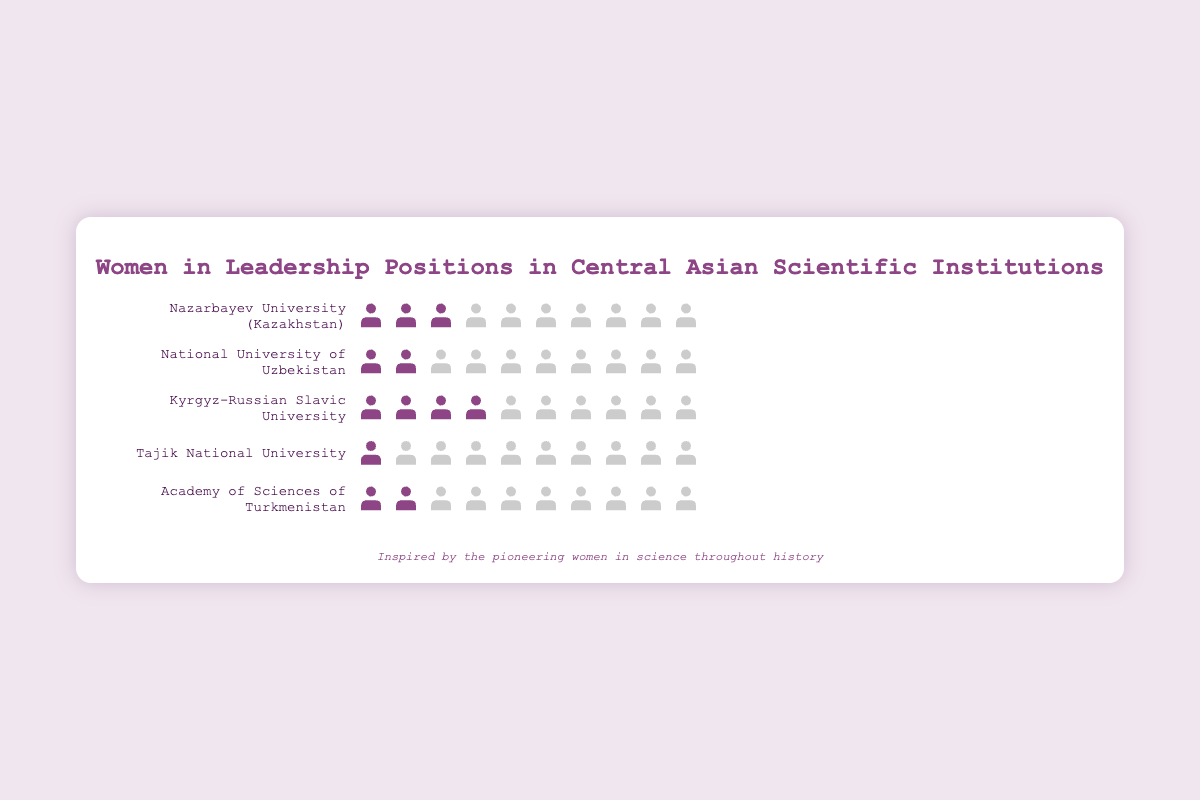What is the title of the Isotype Plot? The title of the Isotype Plot is located at the top of the chart and provides a summary of the plot’s content, indicating that the figure is about women in leadership positions in Central Asian scientific institutions.
Answer: Women in Leadership Positions in Central Asian Scientific Institutions Which institution has the highest number of women leaders? By counting the number of women's icons (figures with purple) for each institution row-wise, it appears that the Kyrgyz-Russian Slavic University has the highest number of women leaders.
Answer: Kyrgyz-Russian Slavic University How many men leaders are there in the Academy of Sciences of Turkmenistan? The Academy of Sciences of Turkmenistan has two women leaders. Since there are 10 total leaders, the number of men leaders is the difference between the total leaders and women leaders, which is 10 - 2.
Answer: 8 Compare the number of women leaders in Nazarbayev University and Tajik National University. Which one has more women leaders and by how much? Nazarbayev University has 3 women leaders and Tajik National University has 1. The difference in the number of women leaders between these two institutions is 3 - 1.
Answer: Nazarbayev University by 2 What percentage of leaders in the Kyrgyz-Russian Slavic University are women? The Kyrgyz-Russian Slavic University has 4 women leaders out of a total of 10. To find the percentage of women leaders, divide the number of women leaders by the total number of leaders and multiply by 100, or (4 / 10) * 100.
Answer: 40% How many institutions have exactly 2 women leaders? Count the rows where exactly two women’s icons (figures with purple) are present. These institutions are the National University of Uzbekistan and the Academy of Sciences of Turkmenistan.
Answer: 2 Which institution out of all the listed has the lowest representation of women in leadership positions? The institution with the lowest number of women’s icons (figures with purple) is the Tajik National University with only one woman leader.
Answer: Tajik National University What is the total number of women leaders across all listed institutions? Sum the number of women leaders from each institution: 3 (Nazarbayev) + 2 (Uzbekistan) + 4 (Kyrgyz-Russian) + 1 (Tajik) + 2 (Turkmenistan).
Answer: 12 If we consider an institution with a ratio of women to men leaders that is at least 1:2, which institutions meet this criterion? The ratio is calculated for each institution: Nazarbayev University (3:7), National University of Uzbekistan (2:8), Kyrgyz-Russian Slavic University (4:6), Tajik National University (1:9), and Academy of Sciences of Turkmenistan (2:8). The institutions meeting the criterion (ratio >= 1:2) are Nazarbayev University and Kyrgyz-Russian Slavic University.
Answer: Nazarbayev University and Kyrgyz-Russian Slavic University 